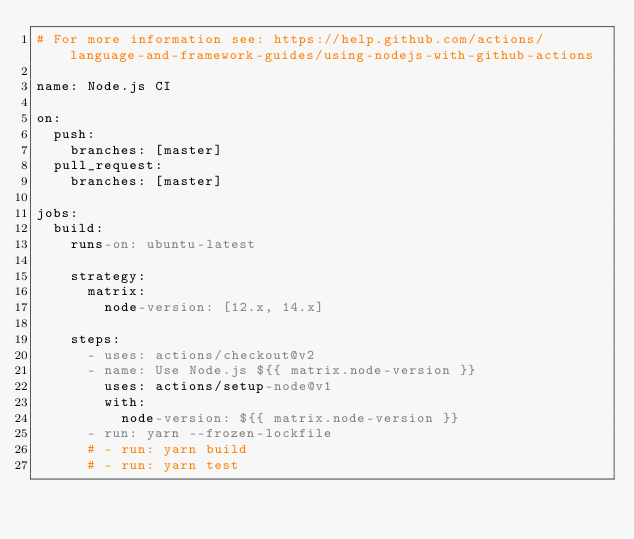Convert code to text. <code><loc_0><loc_0><loc_500><loc_500><_YAML_># For more information see: https://help.github.com/actions/language-and-framework-guides/using-nodejs-with-github-actions

name: Node.js CI

on:
  push:
    branches: [master]
  pull_request:
    branches: [master]

jobs:
  build:
    runs-on: ubuntu-latest

    strategy:
      matrix:
        node-version: [12.x, 14.x]

    steps:
      - uses: actions/checkout@v2
      - name: Use Node.js ${{ matrix.node-version }}
        uses: actions/setup-node@v1
        with:
          node-version: ${{ matrix.node-version }}
      - run: yarn --frozen-lockfile
      # - run: yarn build
      # - run: yarn test
</code> 